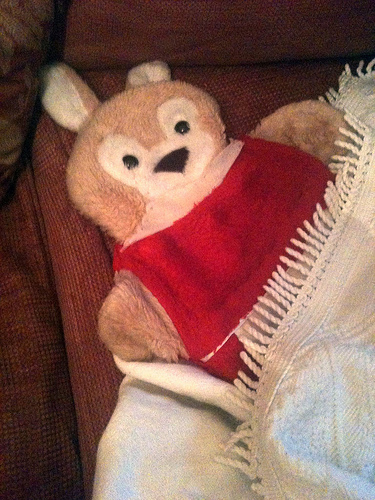<image>
Can you confirm if the toy is above the blanket? No. The toy is not positioned above the blanket. The vertical arrangement shows a different relationship. 